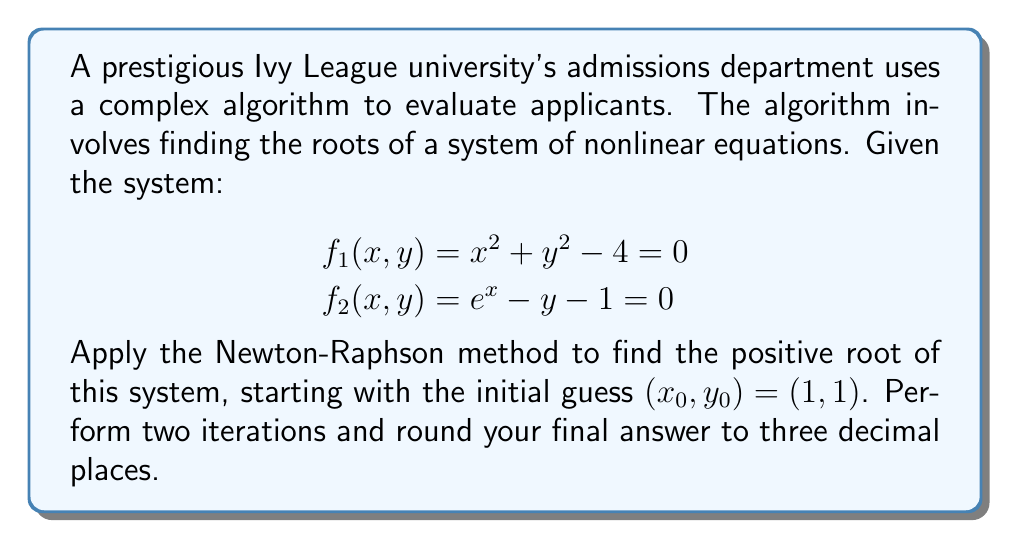Teach me how to tackle this problem. The Newton-Raphson method for a system of nonlinear equations is given by:

$$\mathbf{x}_{n+1} = \mathbf{x}_n - [J(\mathbf{x}_n)]^{-1}\mathbf{f}(\mathbf{x}_n)$$

Where $\mathbf{x}_n$ is the vector of variables, $\mathbf{f}(\mathbf{x}_n)$ is the vector of functions, and $J(\mathbf{x}_n)$ is the Jacobian matrix.

Step 1: Calculate the Jacobian matrix:
$$J(x,y) = \begin{bmatrix}
\frac{\partial f_1}{\partial x} & \frac{\partial f_1}{\partial y} \\
\frac{\partial f_2}{\partial x} & \frac{\partial f_2}{\partial y}
\end{bmatrix} = \begin{bmatrix}
2x & 2y \\
e^x & -1
\end{bmatrix}$$

Step 2: First iteration $(n=0)$
$\mathbf{x}_0 = (1, 1)$

Calculate $\mathbf{f}(\mathbf{x}_0)$:
$$\mathbf{f}(\mathbf{x}_0) = \begin{bmatrix}
1^2 + 1^2 - 4 \\
e^1 - 1 - 1
\end{bmatrix} = \begin{bmatrix}
-2 \\
0.718
\end{bmatrix}$$

Calculate $J(\mathbf{x}_0)$:
$$J(\mathbf{x}_0) = \begin{bmatrix}
2(1) & 2(1) \\
e^1 & -1
\end{bmatrix} = \begin{bmatrix}
2 & 2 \\
e & -1
\end{bmatrix}$$

Calculate $[J(\mathbf{x}_0)]^{-1}$:
$$[J(\mathbf{x}_0)]^{-1} = \frac{1}{-2-2e}\begin{bmatrix}
-1 & -2 \\
-e & 2
\end{bmatrix} \approx \begin{bmatrix}
-0.195 & -0.390 \\
-0.530 & 0.390
\end{bmatrix}$$

Calculate $\mathbf{x}_1$:
$$\mathbf{x}_1 = \begin{bmatrix}
1 \\
1
\end{bmatrix} - \begin{bmatrix}
-0.195 & -0.390 \\
-0.530 & 0.390
\end{bmatrix}\begin{bmatrix}
-2 \\
0.718
\end{bmatrix} \approx \begin{bmatrix}
1.670 \\
1.345
\end{bmatrix}$$

Step 3: Second iteration $(n=1)$
$\mathbf{x}_1 = (1.670, 1.345)$

Calculate $\mathbf{f}(\mathbf{x}_1)$:
$$\mathbf{f}(\mathbf{x}_1) \approx \begin{bmatrix}
-0.118 \\
0.047
\end{bmatrix}$$

Calculate $J(\mathbf{x}_1)$:
$$J(\mathbf{x}_1) \approx \begin{bmatrix}
3.340 & 2.690 \\
5.312 & -1
\end{bmatrix}$$

Calculate $[J(\mathbf{x}_1)]^{-1}$:
$$[J(\mathbf{x}_1)]^{-1} \approx \begin{bmatrix}
-0.084 & -0.226 \\
-0.446 & -0.281
\end{bmatrix}$$

Calculate $\mathbf{x}_2$:
$$\mathbf{x}_2 \approx \begin{bmatrix}
1.670 \\
1.345
\end{bmatrix} - \begin{bmatrix}
-0.084 & -0.226 \\
-0.446 & -0.281
\end{bmatrix}\begin{bmatrix}
-0.118 \\
0.047
\end{bmatrix} \approx \begin{bmatrix}
1.685 \\
1.321
\end{bmatrix}$$

Rounding to three decimal places, we get $(1.685, 1.321)$.
Answer: $(1.685, 1.321)$ 